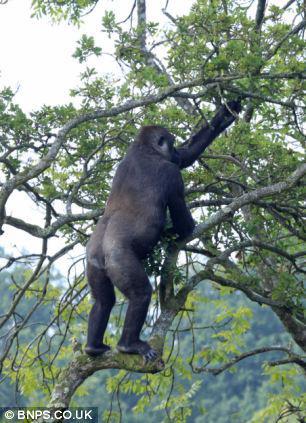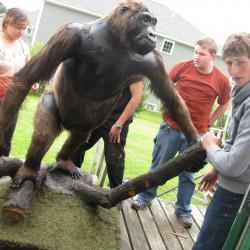The first image is the image on the left, the second image is the image on the right. For the images shown, is this caption "At least one person is present with an ape in one of the images." true? Answer yes or no. Yes. 